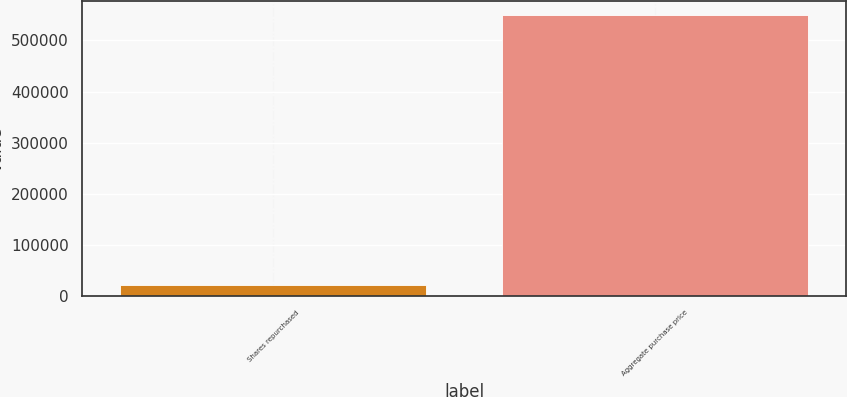Convert chart. <chart><loc_0><loc_0><loc_500><loc_500><bar_chart><fcel>Shares repurchased<fcel>Aggregate purchase price<nl><fcel>22817<fcel>548630<nl></chart> 